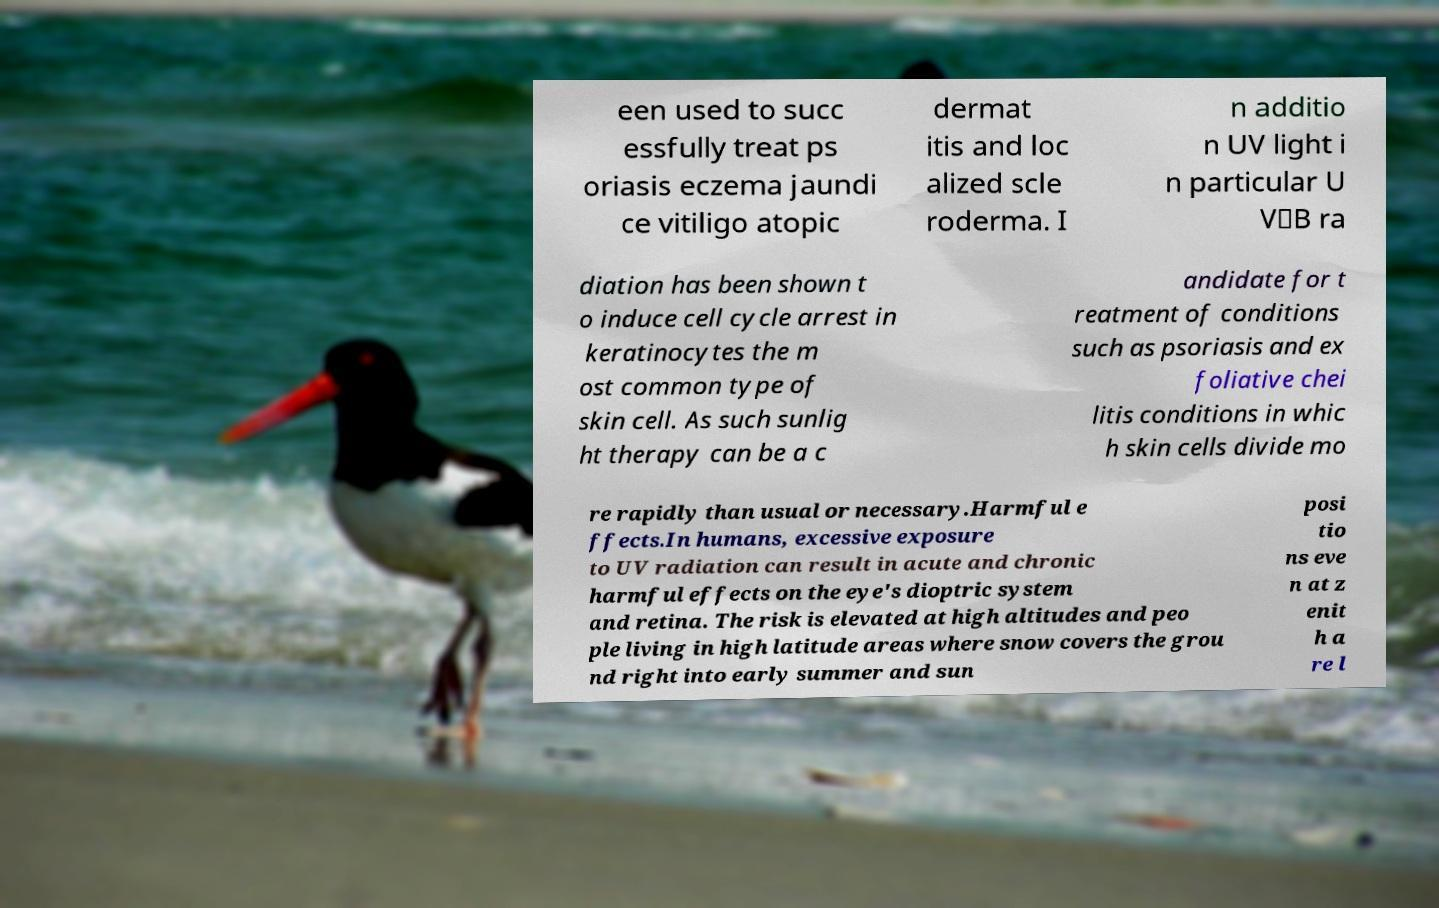Can you read and provide the text displayed in the image?This photo seems to have some interesting text. Can you extract and type it out for me? een used to succ essfully treat ps oriasis eczema jaundi ce vitiligo atopic dermat itis and loc alized scle roderma. I n additio n UV light i n particular U V‑B ra diation has been shown t o induce cell cycle arrest in keratinocytes the m ost common type of skin cell. As such sunlig ht therapy can be a c andidate for t reatment of conditions such as psoriasis and ex foliative chei litis conditions in whic h skin cells divide mo re rapidly than usual or necessary.Harmful e ffects.In humans, excessive exposure to UV radiation can result in acute and chronic harmful effects on the eye's dioptric system and retina. The risk is elevated at high altitudes and peo ple living in high latitude areas where snow covers the grou nd right into early summer and sun posi tio ns eve n at z enit h a re l 